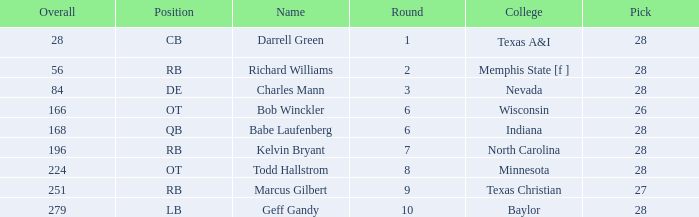What is the lowest round of the position de player with an overall less than 84? None. 